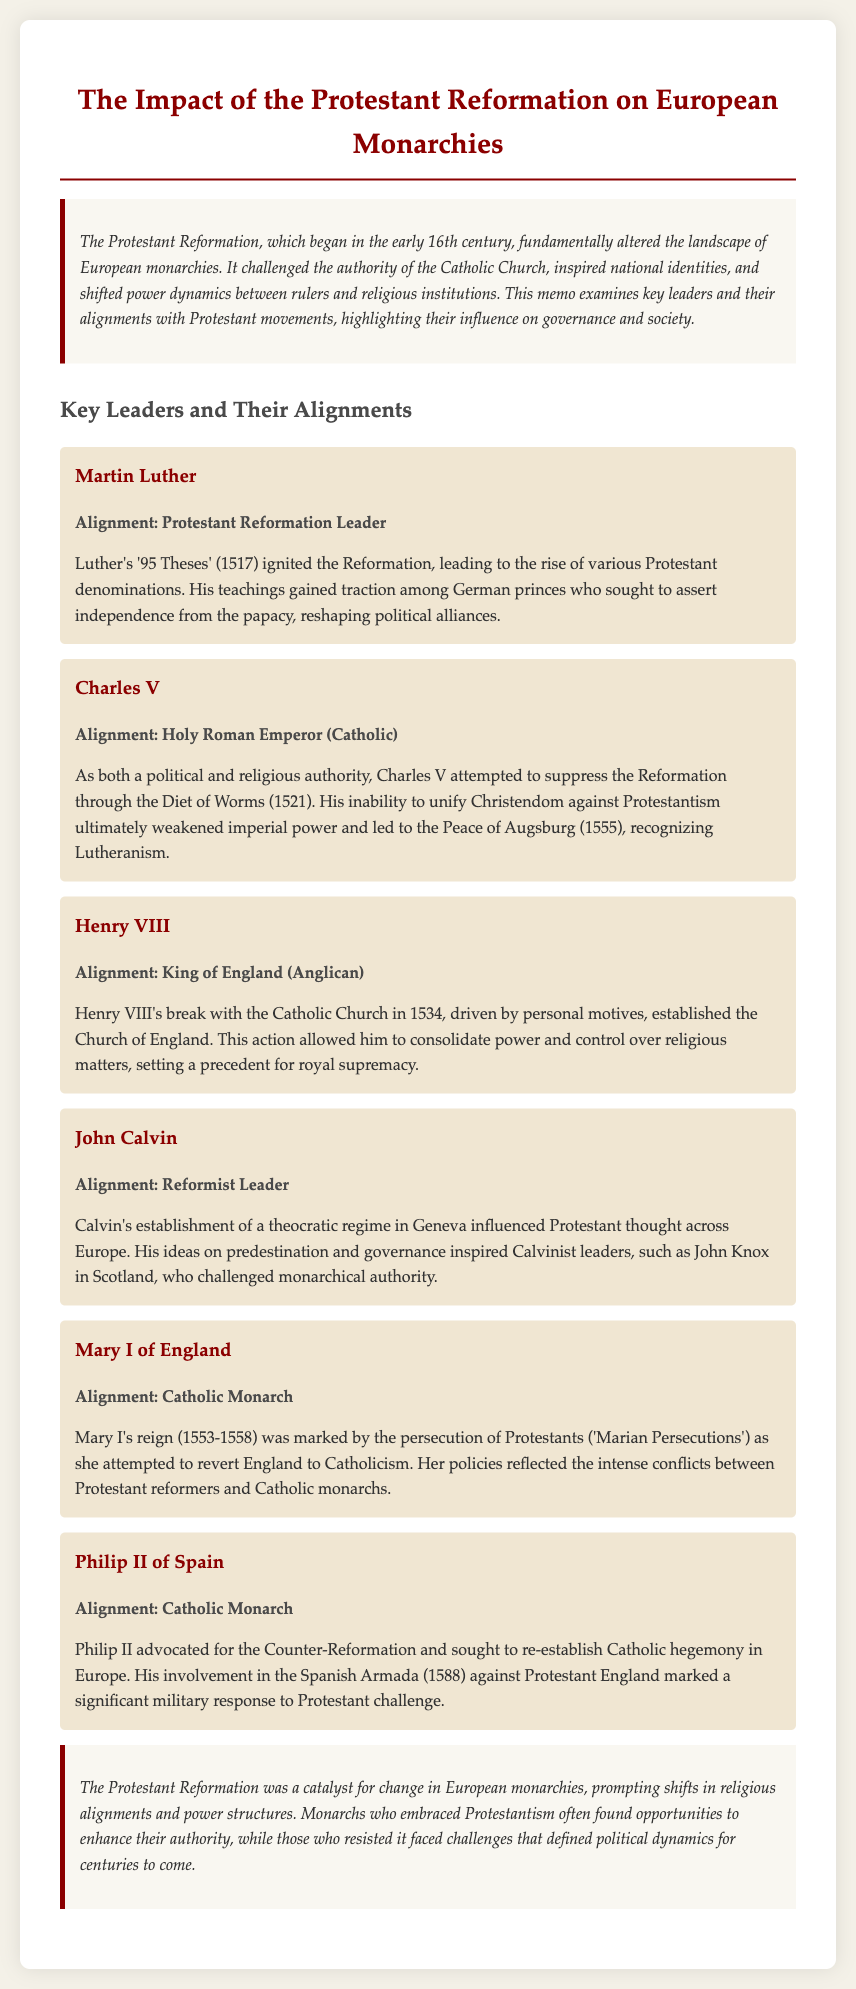What was the title of the document? The title is clearly stated at the beginning of the document, which is "The Impact of the Protestant Reformation on European Monarchies."
Answer: The Impact of the Protestant Reformation on European Monarchies Who authored the '95 Theses'? The document identifies the author of the '95 Theses' as Martin Luther, a key figure in the Protestant Reformation.
Answer: Martin Luther What year did the Diet of Worms take place? The document mentions the Diet of Worms occurred in 1521, a significant event in the context of the Reformation.
Answer: 1521 Which monarch established the Church of England? The memo specifically notes that Henry VIII broke from the Catholic Church to establish the Church of England.
Answer: Henry VIII What alignment is John Calvin associated with? The memo clearly states that John Calvin is aligned with the Reformist movement, indicating his influence on Protestant thought.
Answer: Reformist Leader What was Mary I's alignment during her reign? According to the document, Mary I is identified as a Catholic Monarch who attempted to revert England to Catholicism.
Answer: Catholic Monarch How did the Protestant Reformation affect European monarchies overall? The document concludes by stating that the Protestant Reformation prompted shifts in religious alignments and power structures among monarchies.
Answer: Shifts in religious alignments and power structures In what year did Mary I reign? The document specifies that Mary I's reign lasted from 1553 to 1558, marking her period as a monarch.
Answer: 1553-1558 What significant military action did Philip II take against Protestant England? The memo indicates that Philip II involved himself in the Spanish Armada, a noted military response to Protestant challenges.
Answer: Spanish Armada 